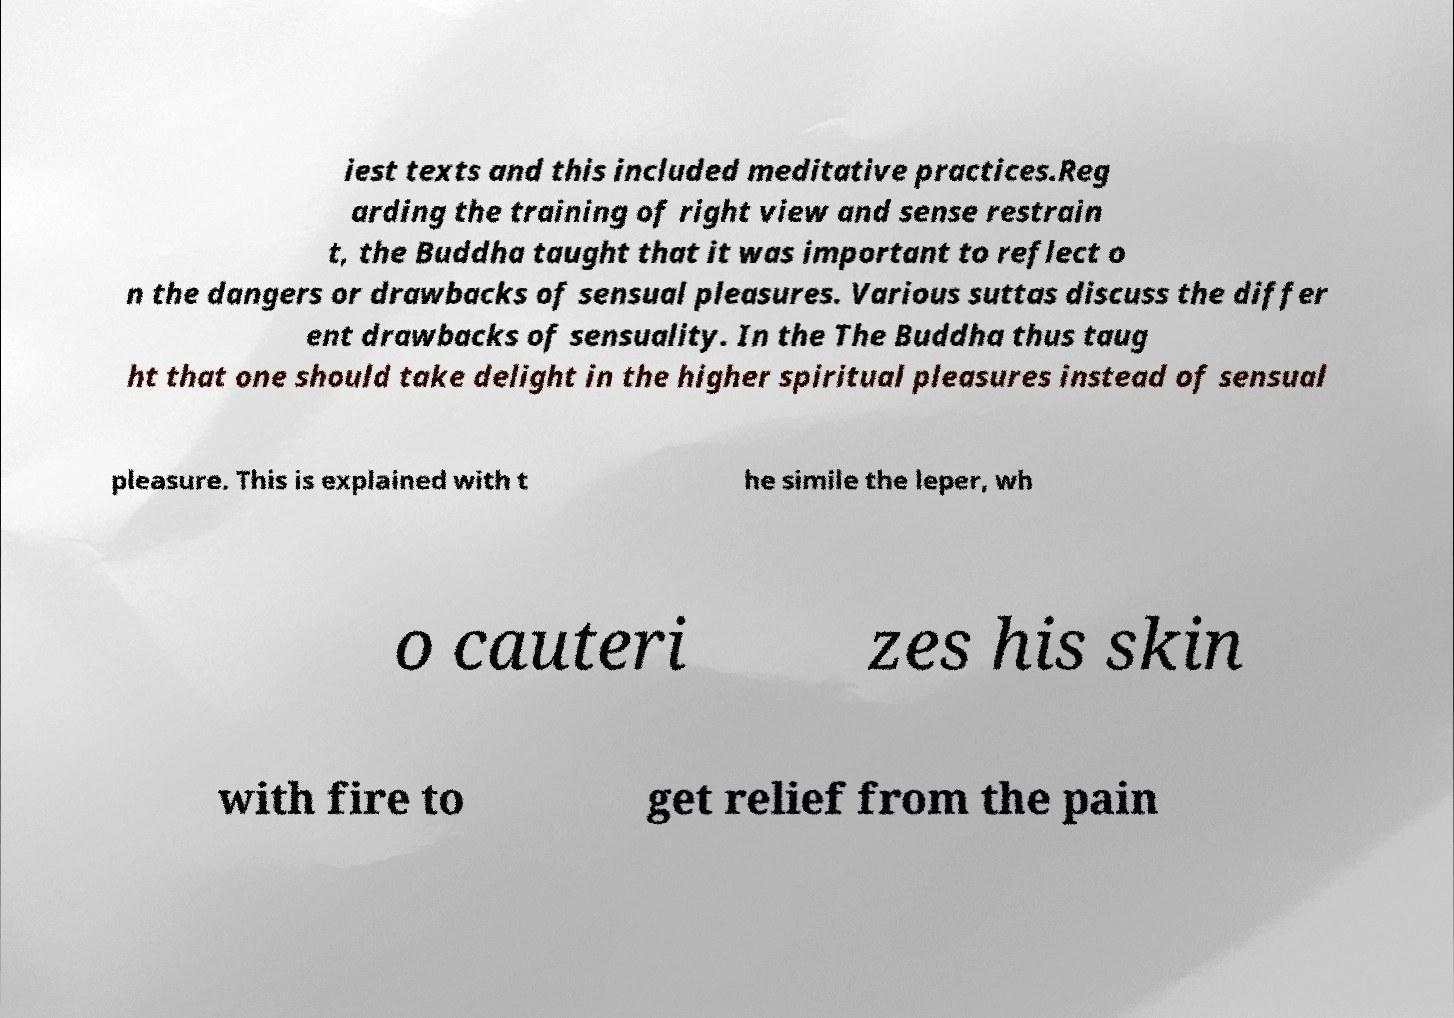There's text embedded in this image that I need extracted. Can you transcribe it verbatim? iest texts and this included meditative practices.Reg arding the training of right view and sense restrain t, the Buddha taught that it was important to reflect o n the dangers or drawbacks of sensual pleasures. Various suttas discuss the differ ent drawbacks of sensuality. In the The Buddha thus taug ht that one should take delight in the higher spiritual pleasures instead of sensual pleasure. This is explained with t he simile the leper, wh o cauteri zes his skin with fire to get relief from the pain 